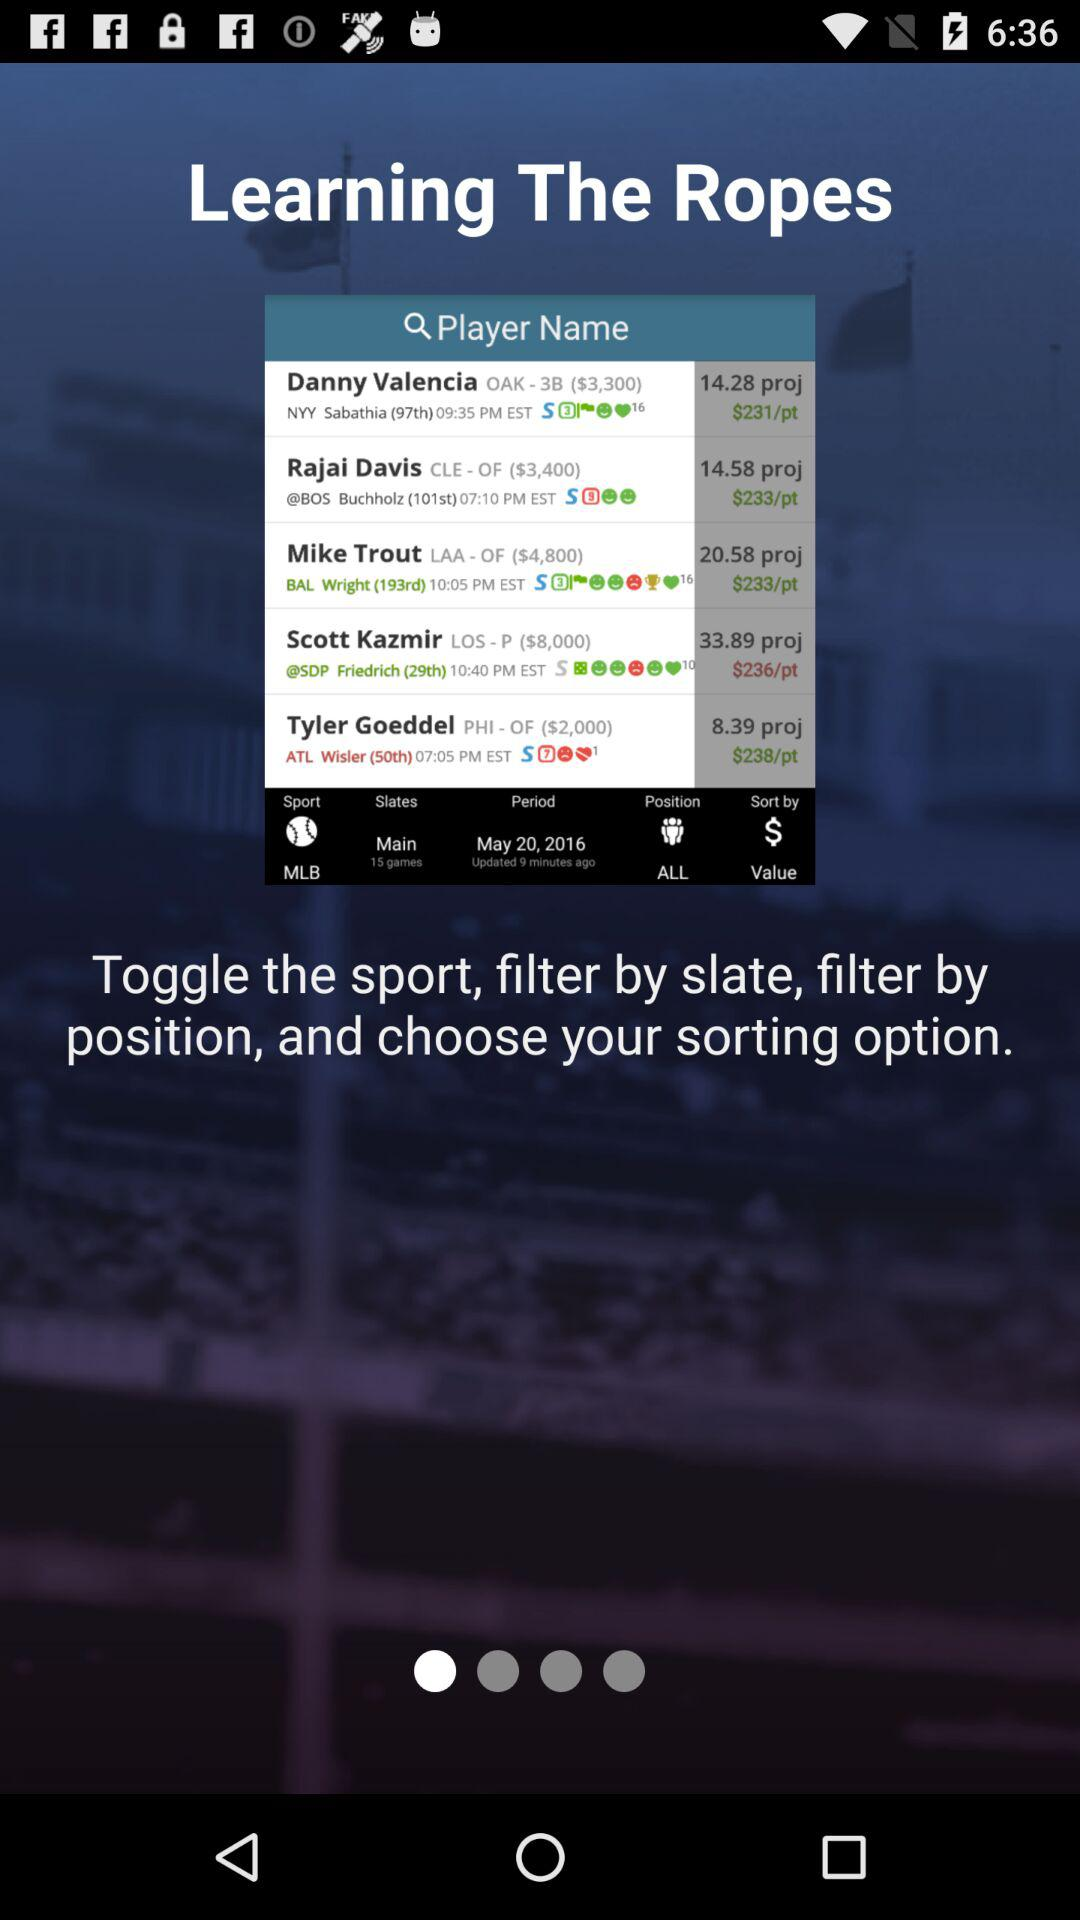How many dollars per point are there for Mike? There are $233 per point for Mike. 